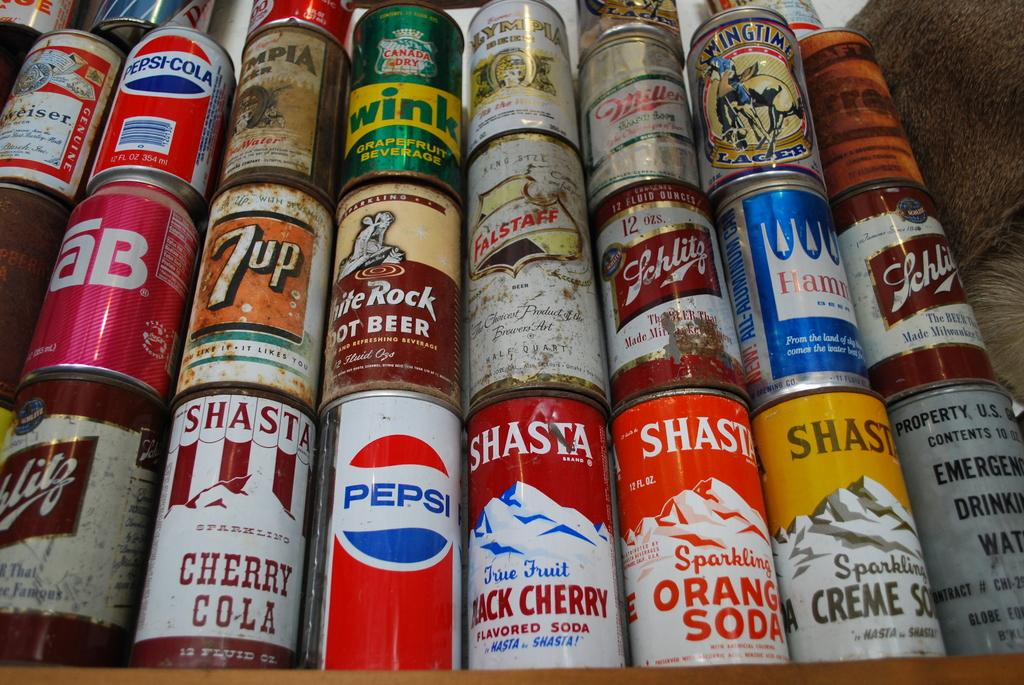<image>
Relay a brief, clear account of the picture shown. A stack of old cans including Shasta Cherry Cola, Pepsi, and 7up. 